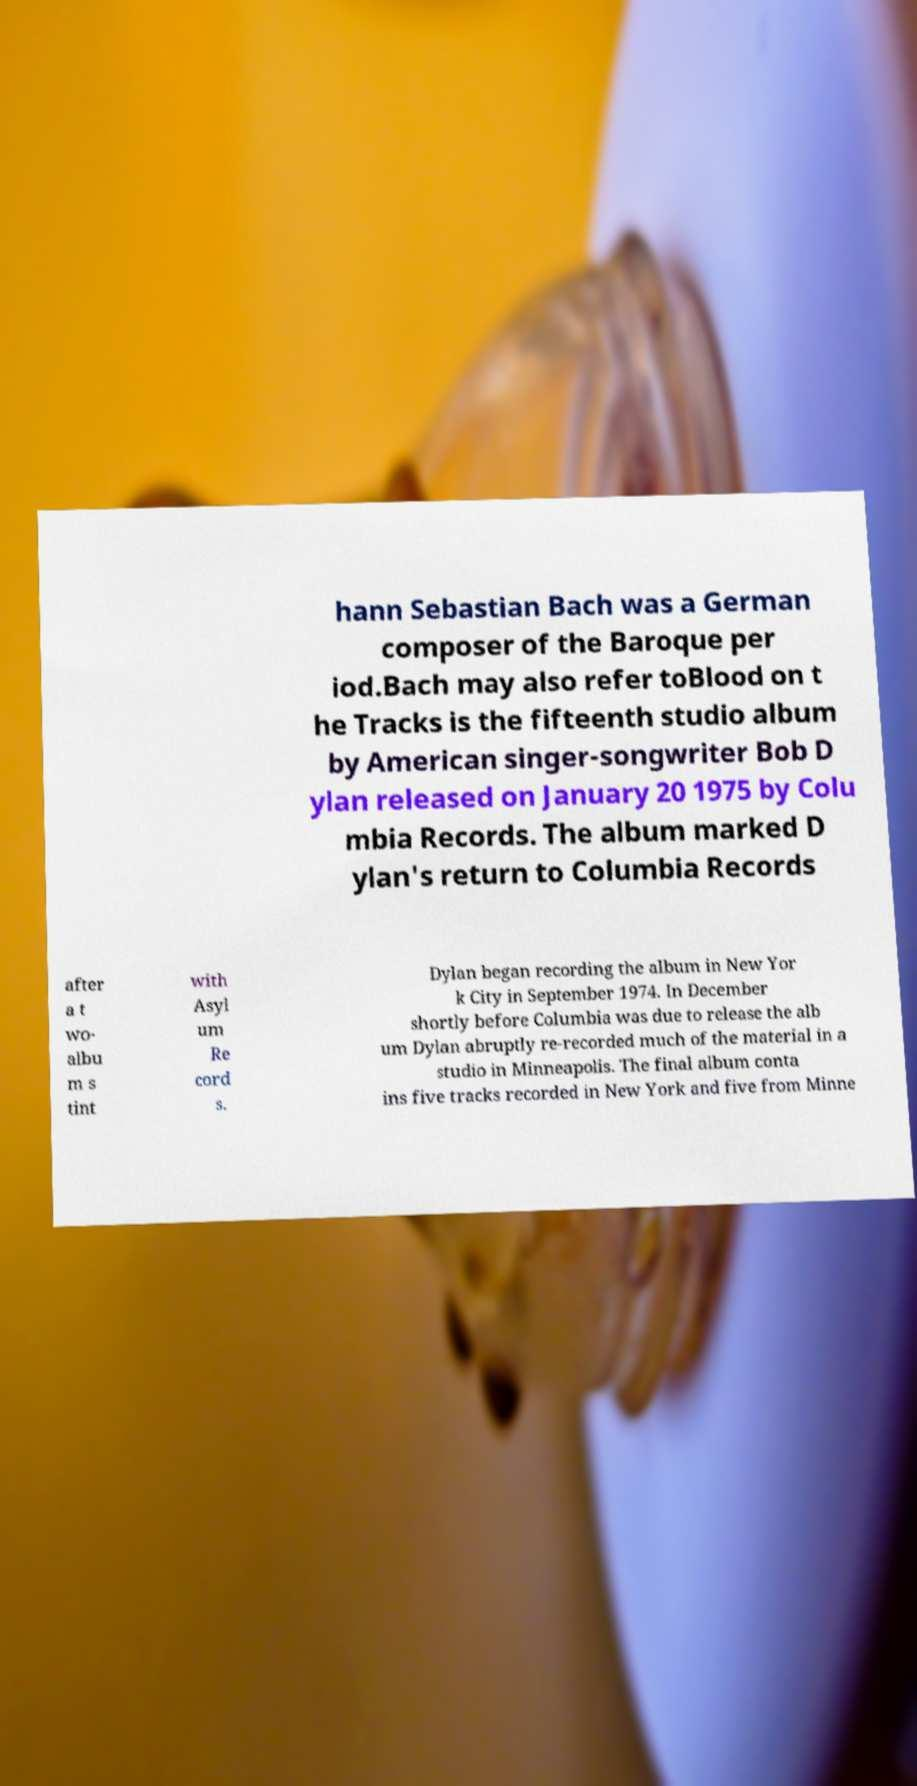I need the written content from this picture converted into text. Can you do that? hann Sebastian Bach was a German composer of the Baroque per iod.Bach may also refer toBlood on t he Tracks is the fifteenth studio album by American singer-songwriter Bob D ylan released on January 20 1975 by Colu mbia Records. The album marked D ylan's return to Columbia Records after a t wo- albu m s tint with Asyl um Re cord s. Dylan began recording the album in New Yor k City in September 1974. In December shortly before Columbia was due to release the alb um Dylan abruptly re-recorded much of the material in a studio in Minneapolis. The final album conta ins five tracks recorded in New York and five from Minne 